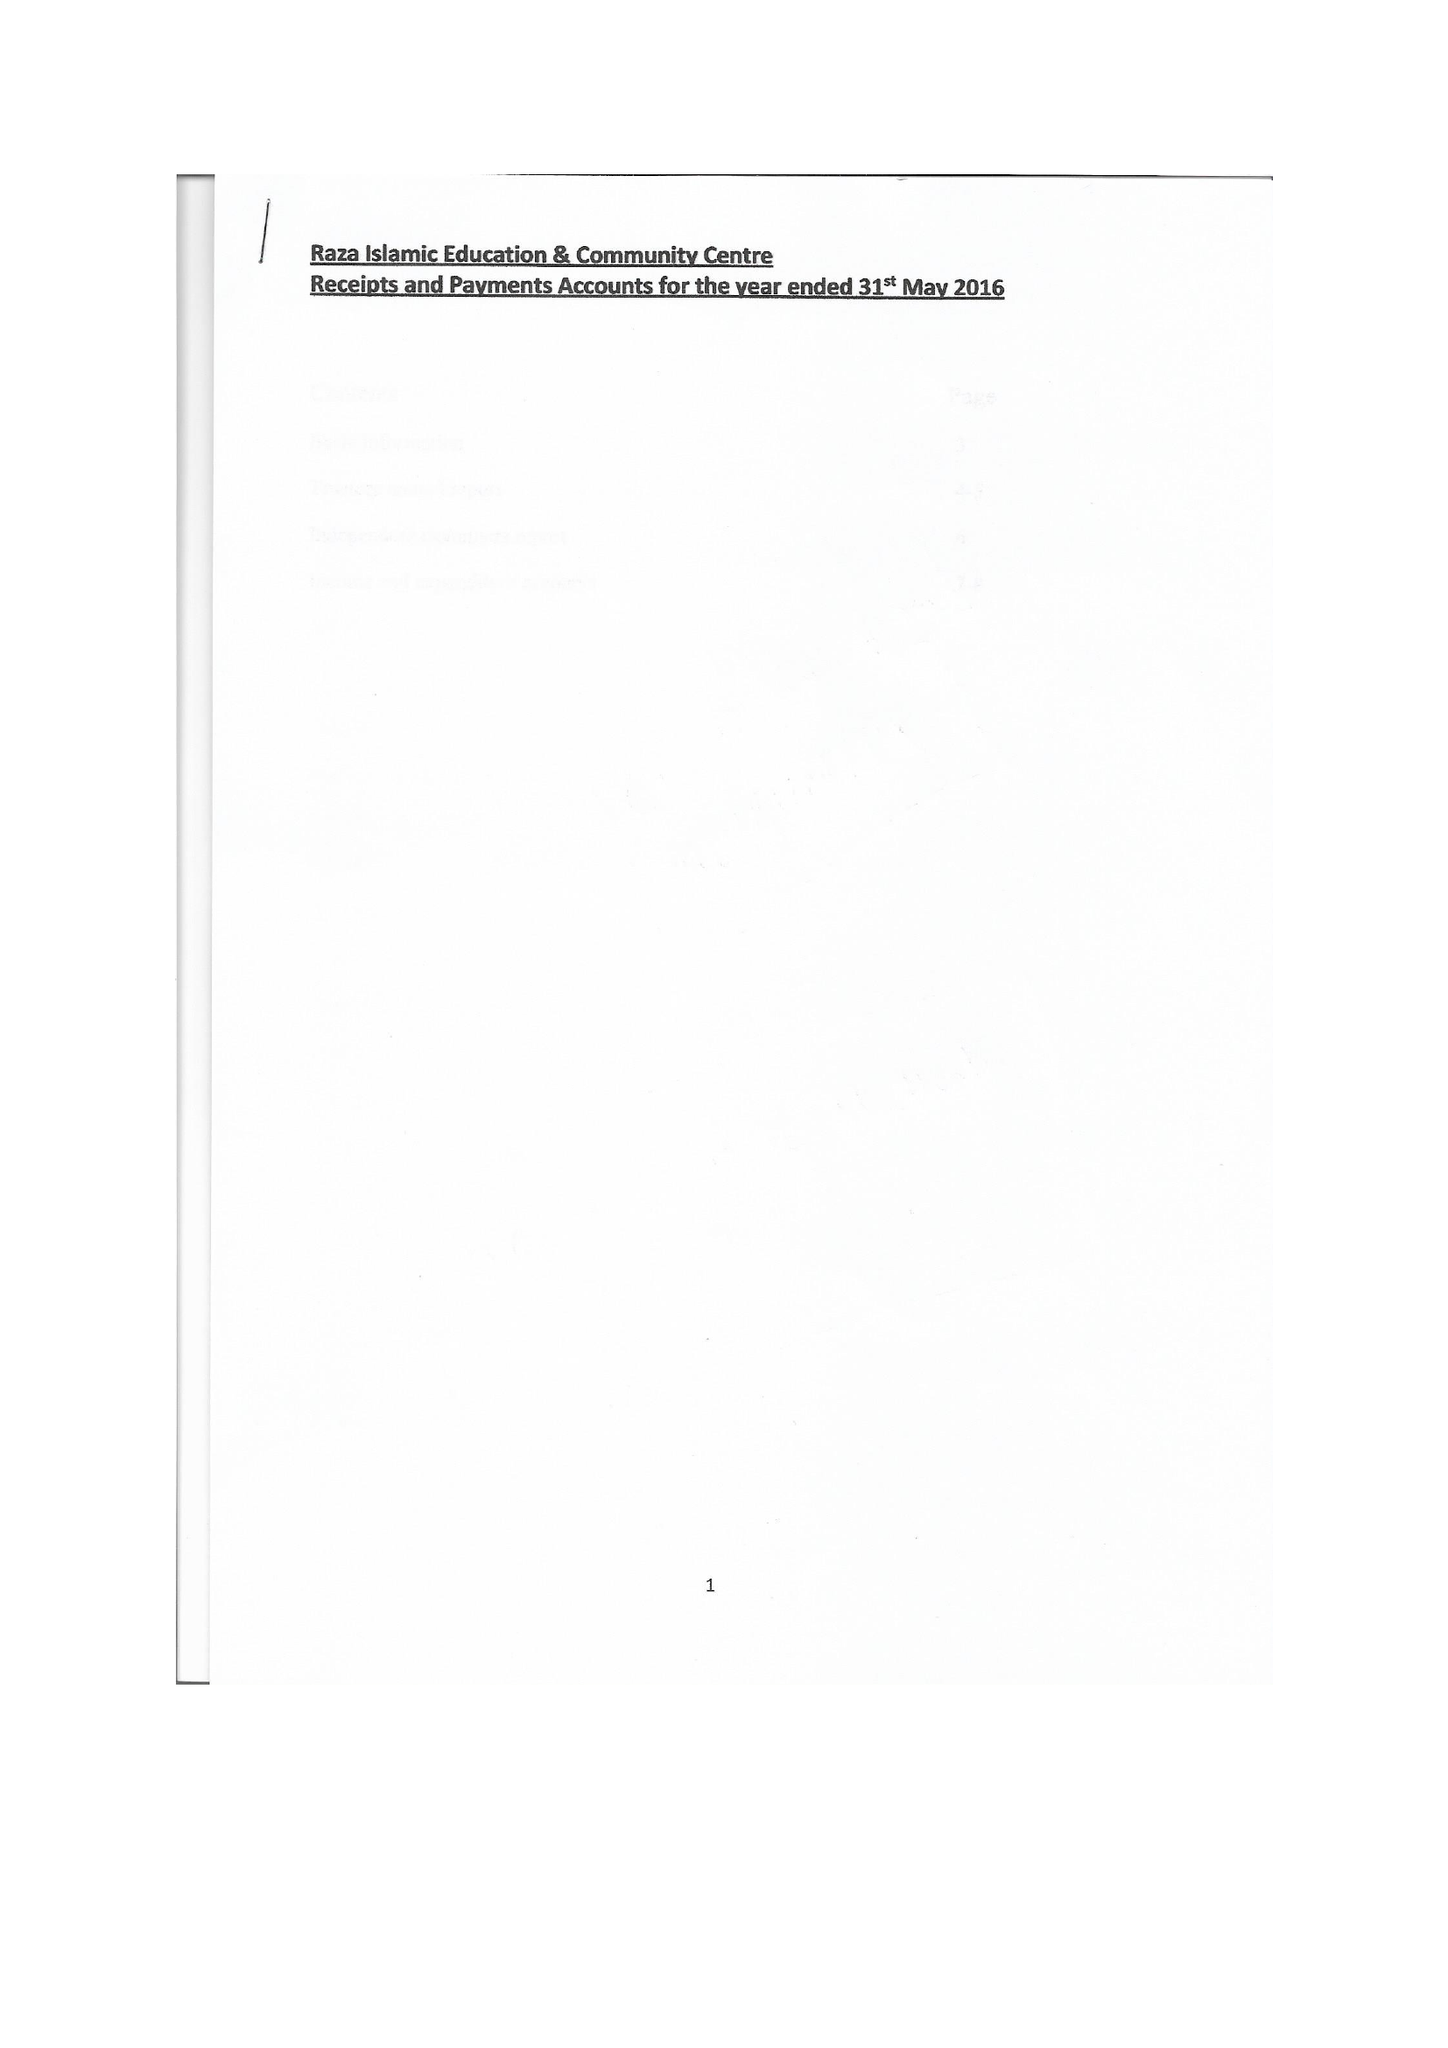What is the value for the address__post_town?
Answer the question using a single word or phrase. DEWSBURY 